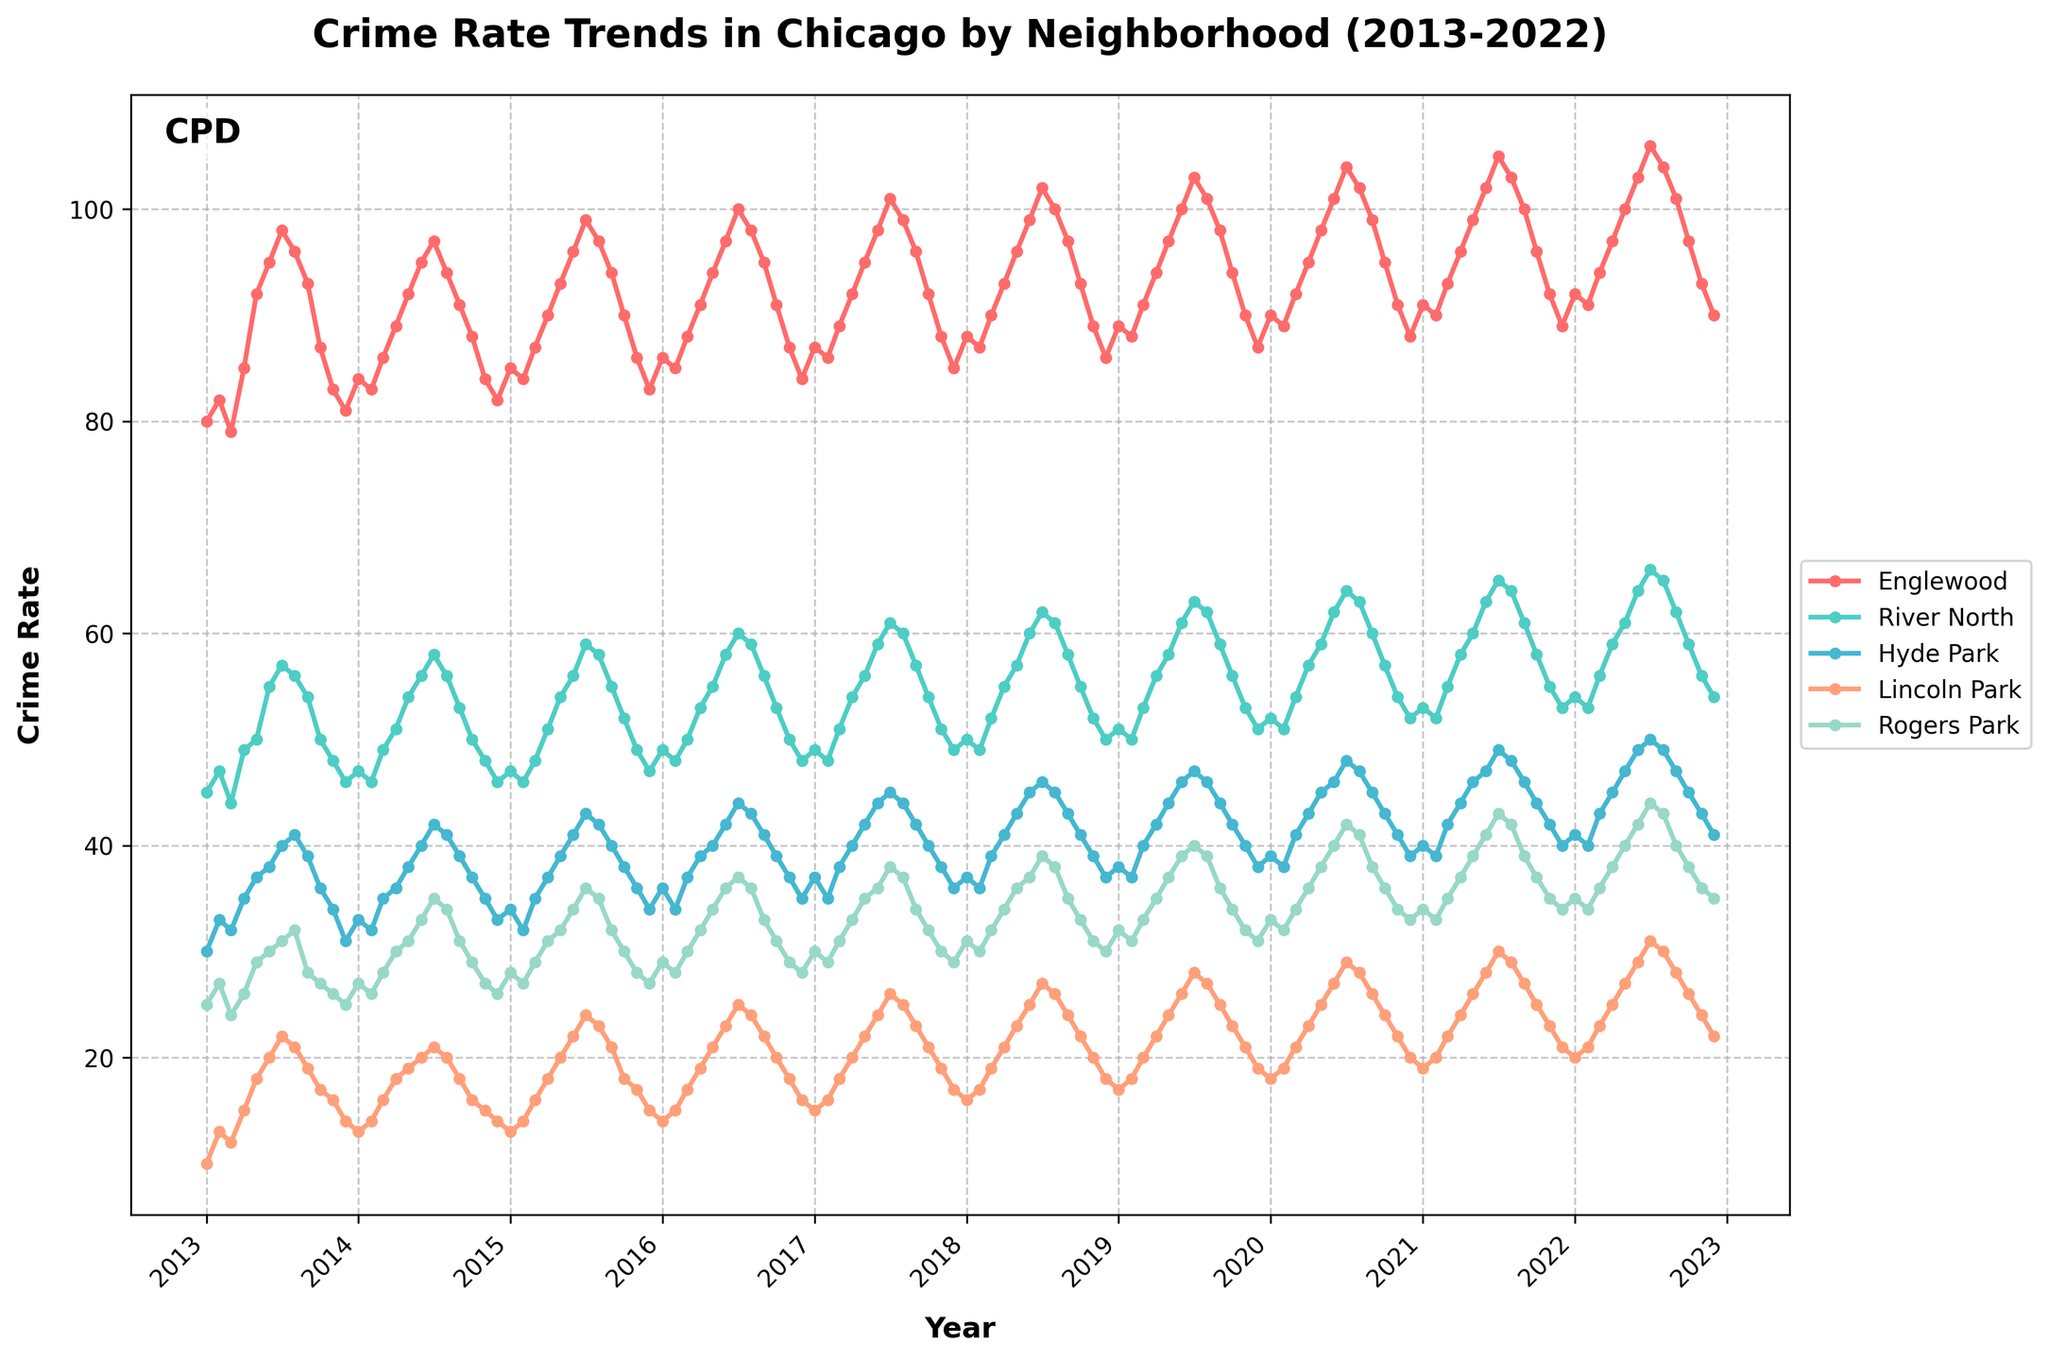What is the title of the plot? The title is usually located at the top of the plot and often describes the main topic of the figure. In this case, it reads "Crime Rate Trends in Chicago by Neighborhood (2013-2022)".
Answer: Crime Rate Trends in Chicago by Neighborhood (2013-2022) How many neighborhoods are represented in the plot? The plot includes multiple lines, each representing a different neighborhood. By counting the labels in the legend, you can determine there are five neighborhoods: Englewood, River North, Hyde Park, Lincoln Park, and Rogers Park.
Answer: 5 Which neighborhood had the highest crime rate in 2022? To find this, look at the end of the time series lines (2022) and identify which line is the highest on the y-axis. Englewood's line is consistently higher than the others.
Answer: Englewood What is the general trend of crime rates in the Lincoln Park neighborhood over the decade? Observe the line corresponding to Lincoln Park, which is identified by the legend. Notice if it generally increases, decreases, or remains stable from 2013 to 2022. Lincoln Park shows a steady increase over the years.
Answer: Increasing Which year had the overall highest crime rate across all neighborhoods, and what was the rate in Englewood that year? Look for the year where most lines peak the highest. The year 2022 seems to have the highest crime rates. Specifically, Englewood had the highest rate in July 2022, with a crime rate of 106.
Answer: 2022; 106 Between which two consecutive years did River North see the highest increase in crime rates? Identify the line corresponding to River North. Compare the difference in crime rates between consecutive years to see where the steepest slope is. The largest increase for River North is from 2019 to 2020.
Answer: 2019-2020 By how much did the crime rate in Hyde Park increase from January 2013 to December 2022? Find the crime rates for Hyde Park at the start (January 2013) and end (December 2022) of the data series. Subtract the rate in January 2013 from the rate in December 2022: 41 - 30 = 11.
Answer: 11 What month typically shows a peak in crime rates for most neighborhoods each year? Look at the periodical peaks in the time series for the different neighborhoods. Most neighborhoods such as Englewood and River North show high peaks in July.
Answer: July Did Rogers Park ever surpass Hyde Park in crime rates during the last five years of the data? Observe the lines for Rogers Park and Hyde Park between 2018-2022. Check if the line for Rogers Park is ever above Hyde Park. In August 2022, both lines are very close but Rogers Park never surpasses Hyde Park significantly.
Answer: No 